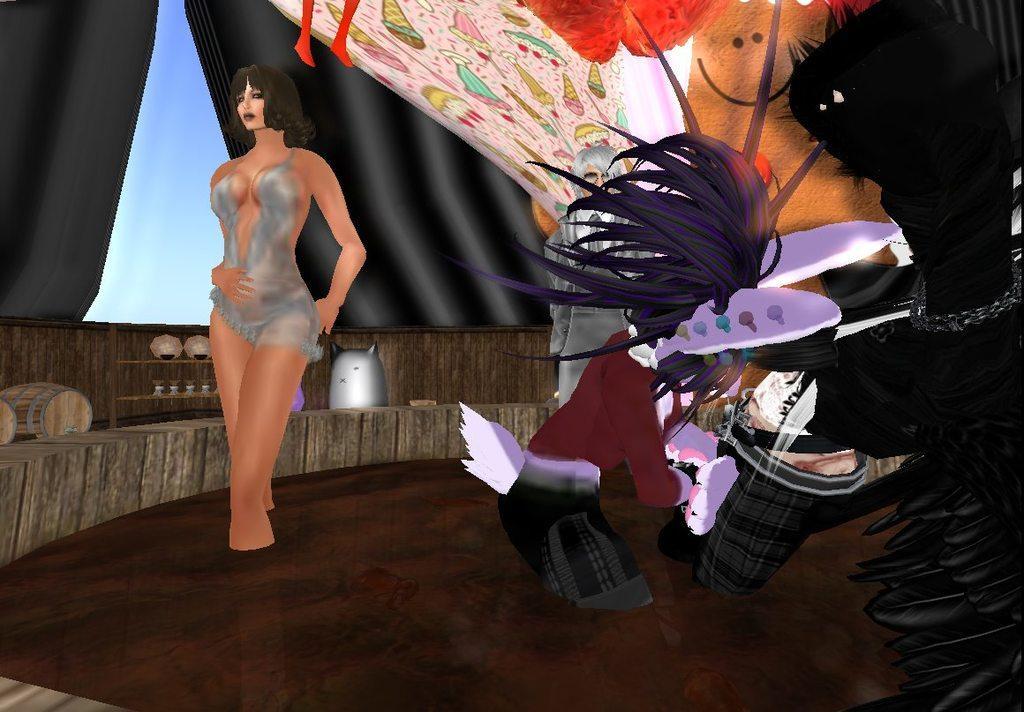In one or two sentences, can you explain what this image depicts? This is an animated image, in this picture there are people and we can see barrel, curtains and objects. In the background of the image we can see the sky. 